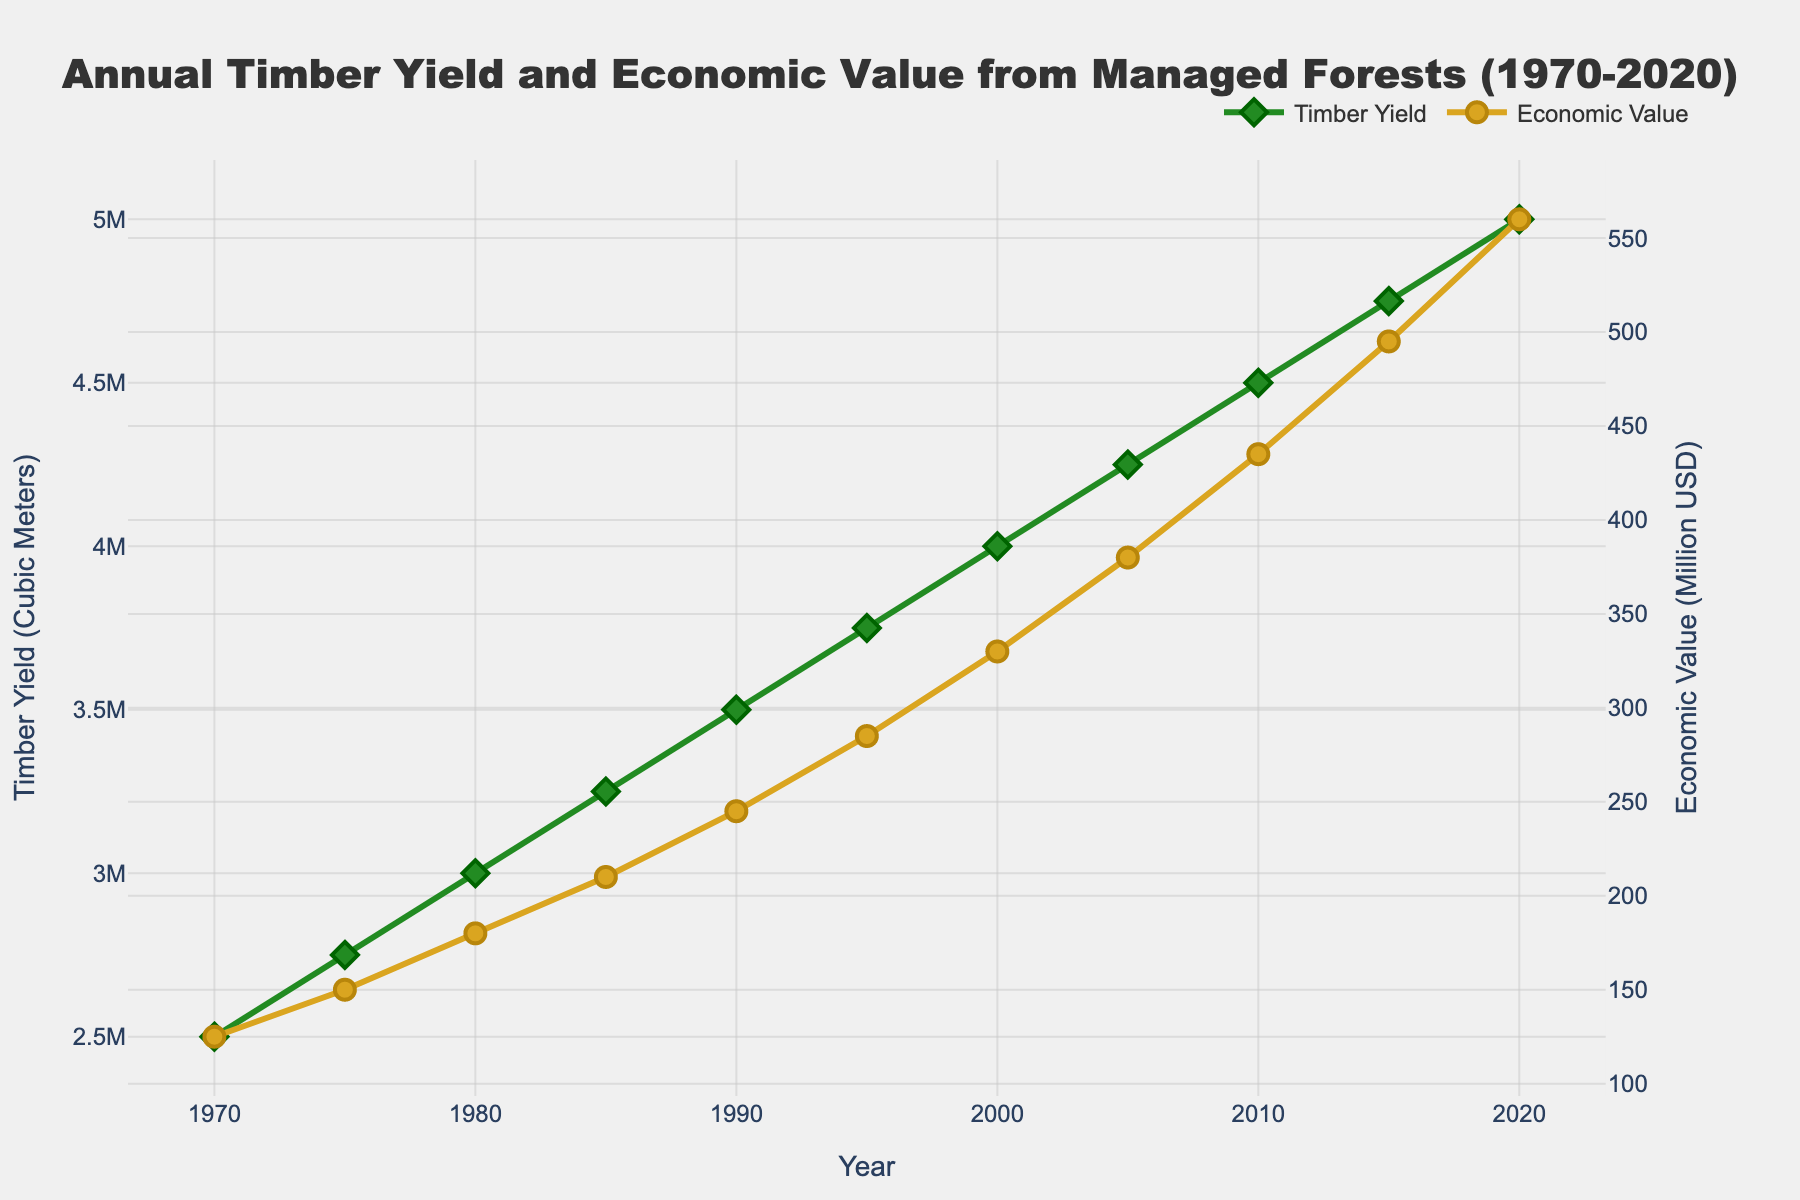What is the timber yield in cubic meters in the year 2000? The data for the timber yield in cubic meters can be directly read off from the line labeled "Timber Yield" for the year 2000. From the figure, the height of the green line at the year 2000 indicates a yield of 4,000,000 cubic meters.
Answer: 4,000,000 cubic meters How much did the economic value increase from 1980 to 2020? First locate the economic value for the years 1980 and 2020 from the gold line. In 1980, the value is 180 million USD, and in 2020, it's 560 million USD. Calculate the difference: 560 million USD - 180 million USD = 380 million USD.
Answer: 380 million USD In which decade did the timber yield see the highest growth rate? To find the decade with the highest growth rate, examine the slopes of the green line over each decade. The decade 1970-1980 shows a yield change from 2,500,000 to 3,000,000 (500,000), 1980-1990 from 3,000,000 to 3,500,000 (500,000), 1990-2000 from 3,500,000 to 4,000,000 (500,000), and 2000-2010 from 4,000,000 to 4,500,000 (500,000). The steepest increase occurs in the period 2010-2020, where the yield goes from 4,500,000 to 5,000,000 (500,000). So this decade shows the highest growth.
Answer: 2010-2020 Which year shows the highest economic value of managed forests? The highest point on the gold line indicates the year with the highest economic value. From the figure, this is the year 2020 with an economic value of 560 million USD.
Answer: 2020 How does the economic value in 1990 compare to the timber yield in 1990? Find the values for both economic value and timber yield in 1990. The gold line shows 245 million USD for economic value, while the green line shows a yield of 3,500,000 cubic meters. The economic value (245) is not directly comparable in units to timber yield (3,500,000), but relative magnitude in the respective units shows economic value of 245 million USD is significant in its metric.
Answer: Economic value: 245 million USD, Timber yield: 3,500,000 cubic meters By how much did the timber yield increase from 1970 to 1990? Find the timber yield values for 1970 and 1990 from the green line. Timber yield in 1970 is 2,500,000 cubic meters, and in 1990 it is 3,500,000 cubic meters. Calculate the increase: 3,500,000 - 2,500,000 = 1,000,000 cubic meters.
Answer: 1,000,000 cubic meters Is there a decade when both timber yield and economic value increased linearly? To check linearity, observe the rate changes of both the green and gold lines over each decade. Both lines appear to be steadily increasing, without abrupt changes, throughout all decades, indicating a fairly linear increase. However, the period from 2000 to 2010 shows uniformity with fewer fluctuations compared to other periods, indicating linear growth.
Answer: 2000-2010 What's the average annual timber yield over the last three decades (1990-2020)? Locate the yield values for 1990, 2000, 2010, and 2020 (3,500,000; 4,000,000; 4,500,000; 5,000,000). Calculate the average: (3,500,000 + 4,000,000 + 4,500,000 + 5,000,000)/4 = 17,000,000/4 = 4,250,000 cubic meters.
Answer: 4,250,000 cubic meters How did the economic value change between the most recent two data points? Check the values for 2015 and 2020 on the gold line. In 2015, the value is 495 million USD, and in 2020, it is 560 million USD. The change is 560 - 495 = 65 million USD.
Answer: 65 million USD 